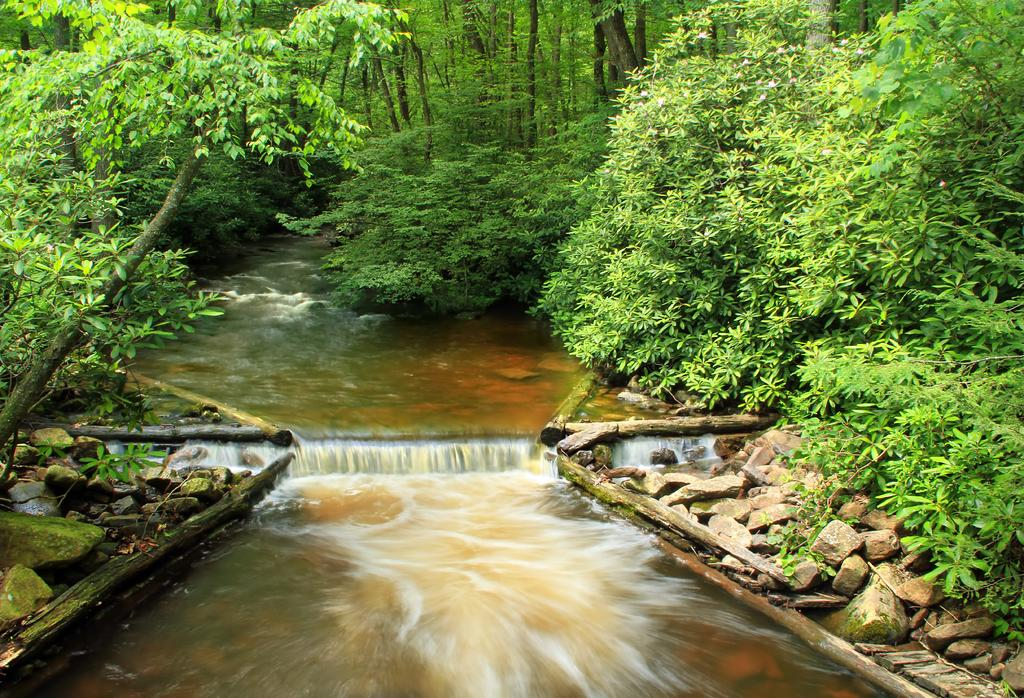What is located at the bottom of the image? There is a river at the bottom of the image. What can be seen on the right side of the image? There are stones on the right side of the image. What is present on the left side of the image? There are stones on the left side of the image. What type of vegetation is visible in the background of the image? There are many trees in the background of the image. What type of songs can be heard coming from the river in the image? There is no indication in the image that songs can be heard coming from the river, as the image only shows a river and stones on both sides. 